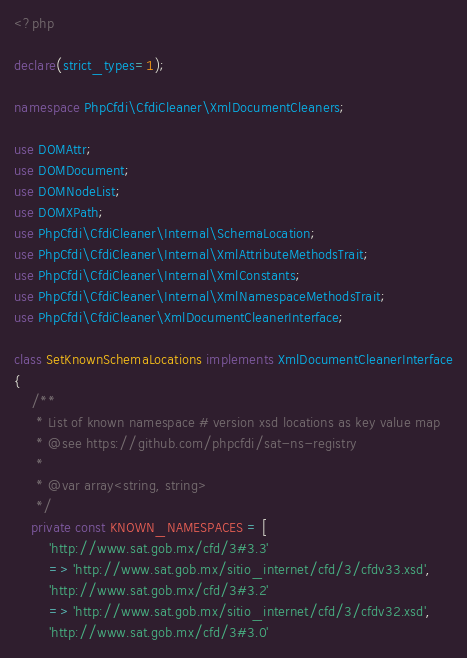Convert code to text. <code><loc_0><loc_0><loc_500><loc_500><_PHP_><?php

declare(strict_types=1);

namespace PhpCfdi\CfdiCleaner\XmlDocumentCleaners;

use DOMAttr;
use DOMDocument;
use DOMNodeList;
use DOMXPath;
use PhpCfdi\CfdiCleaner\Internal\SchemaLocation;
use PhpCfdi\CfdiCleaner\Internal\XmlAttributeMethodsTrait;
use PhpCfdi\CfdiCleaner\Internal\XmlConstants;
use PhpCfdi\CfdiCleaner\Internal\XmlNamespaceMethodsTrait;
use PhpCfdi\CfdiCleaner\XmlDocumentCleanerInterface;

class SetKnownSchemaLocations implements XmlDocumentCleanerInterface
{
    /**
     * List of known namespace # version xsd locations as key value map
     * @see https://github.com/phpcfdi/sat-ns-registry
     *
     * @var array<string, string>
     */
    private const KNOWN_NAMESPACES = [
        'http://www.sat.gob.mx/cfd/3#3.3'
        => 'http://www.sat.gob.mx/sitio_internet/cfd/3/cfdv33.xsd',
        'http://www.sat.gob.mx/cfd/3#3.2'
        => 'http://www.sat.gob.mx/sitio_internet/cfd/3/cfdv32.xsd',
        'http://www.sat.gob.mx/cfd/3#3.0'</code> 